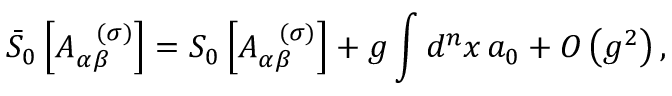Convert formula to latex. <formula><loc_0><loc_0><loc_500><loc_500>\bar { S } _ { 0 } \left [ A _ { \alpha \beta } ^ { \, ( \sigma ) } \right ] = S _ { 0 } \left [ A _ { \alpha \beta } ^ { \, ( \sigma ) } \right ] + g \int d ^ { n } x \, a _ { 0 } + O \left ( g ^ { 2 } \right ) ,</formula> 